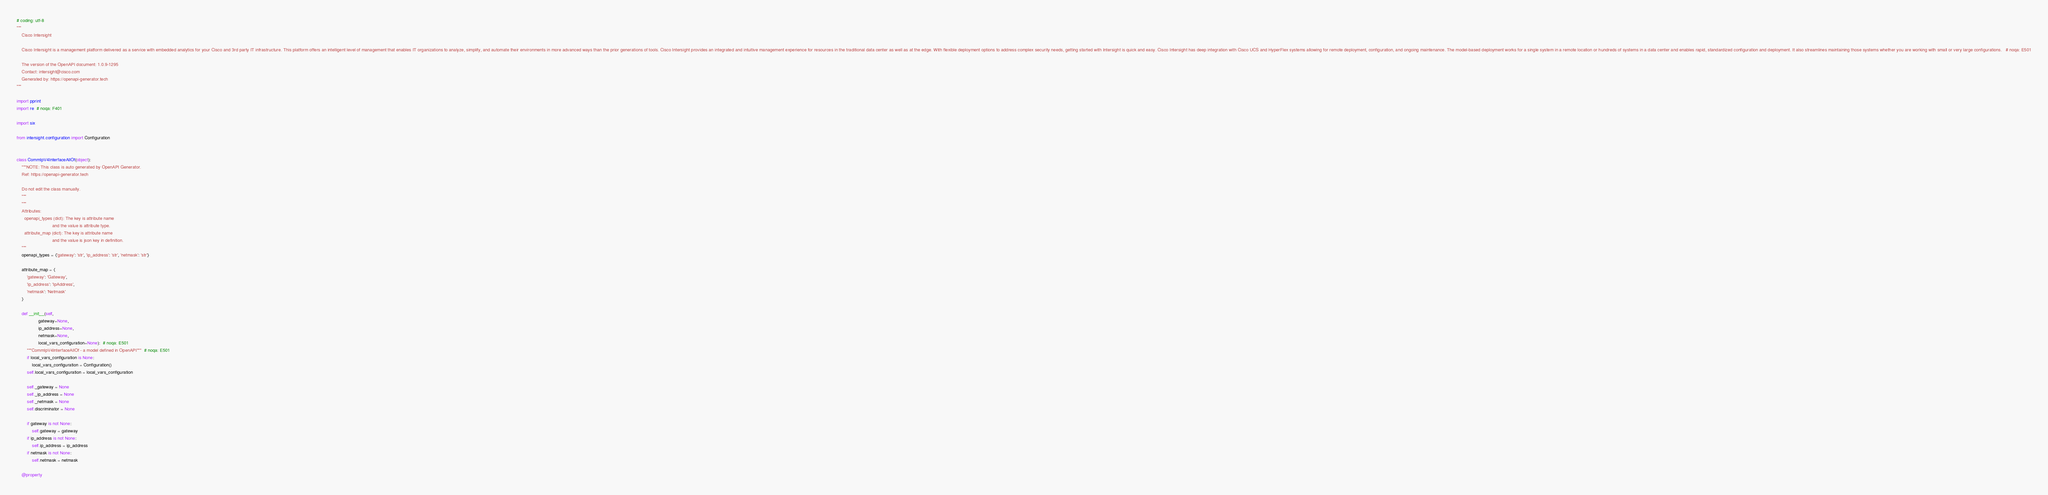Convert code to text. <code><loc_0><loc_0><loc_500><loc_500><_Python_># coding: utf-8
"""
    Cisco Intersight

    Cisco Intersight is a management platform delivered as a service with embedded analytics for your Cisco and 3rd party IT infrastructure. This platform offers an intelligent level of management that enables IT organizations to analyze, simplify, and automate their environments in more advanced ways than the prior generations of tools. Cisco Intersight provides an integrated and intuitive management experience for resources in the traditional data center as well as at the edge. With flexible deployment options to address complex security needs, getting started with Intersight is quick and easy. Cisco Intersight has deep integration with Cisco UCS and HyperFlex systems allowing for remote deployment, configuration, and ongoing maintenance. The model-based deployment works for a single system in a remote location or hundreds of systems in a data center and enables rapid, standardized configuration and deployment. It also streamlines maintaining those systems whether you are working with small or very large configurations.   # noqa: E501

    The version of the OpenAPI document: 1.0.9-1295
    Contact: intersight@cisco.com
    Generated by: https://openapi-generator.tech
"""

import pprint
import re  # noqa: F401

import six

from intersight.configuration import Configuration


class CommIpV4InterfaceAllOf(object):
    """NOTE: This class is auto generated by OpenAPI Generator.
    Ref: https://openapi-generator.tech

    Do not edit the class manually.
    """
    """
    Attributes:
      openapi_types (dict): The key is attribute name
                            and the value is attribute type.
      attribute_map (dict): The key is attribute name
                            and the value is json key in definition.
    """
    openapi_types = {'gateway': 'str', 'ip_address': 'str', 'netmask': 'str'}

    attribute_map = {
        'gateway': 'Gateway',
        'ip_address': 'IpAddress',
        'netmask': 'Netmask'
    }

    def __init__(self,
                 gateway=None,
                 ip_address=None,
                 netmask=None,
                 local_vars_configuration=None):  # noqa: E501
        """CommIpV4InterfaceAllOf - a model defined in OpenAPI"""  # noqa: E501
        if local_vars_configuration is None:
            local_vars_configuration = Configuration()
        self.local_vars_configuration = local_vars_configuration

        self._gateway = None
        self._ip_address = None
        self._netmask = None
        self.discriminator = None

        if gateway is not None:
            self.gateway = gateway
        if ip_address is not None:
            self.ip_address = ip_address
        if netmask is not None:
            self.netmask = netmask

    @property</code> 